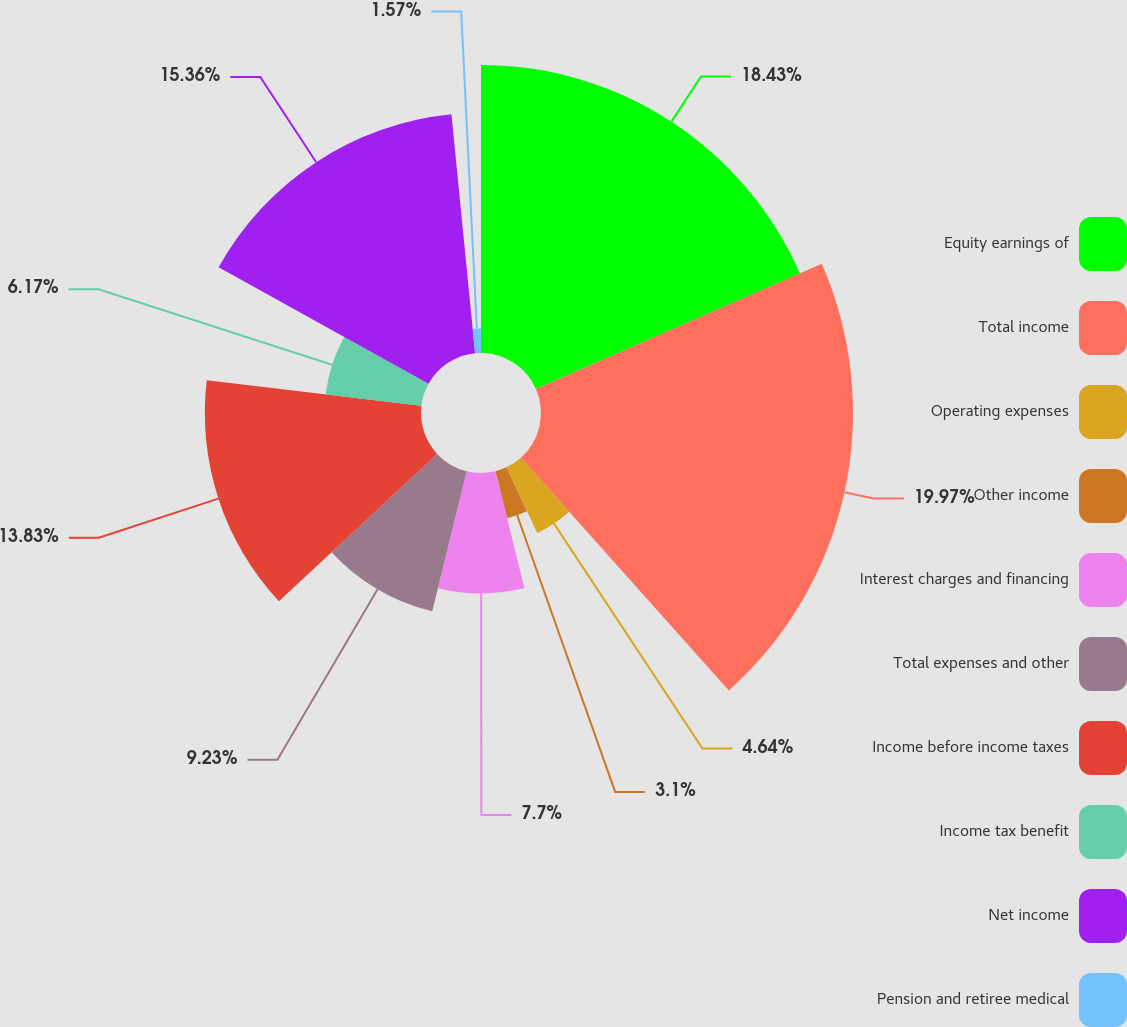Convert chart. <chart><loc_0><loc_0><loc_500><loc_500><pie_chart><fcel>Equity earnings of<fcel>Total income<fcel>Operating expenses<fcel>Other income<fcel>Interest charges and financing<fcel>Total expenses and other<fcel>Income before income taxes<fcel>Income tax benefit<fcel>Net income<fcel>Pension and retiree medical<nl><fcel>18.43%<fcel>19.96%<fcel>4.64%<fcel>3.1%<fcel>7.7%<fcel>9.23%<fcel>13.83%<fcel>6.17%<fcel>15.36%<fcel>1.57%<nl></chart> 